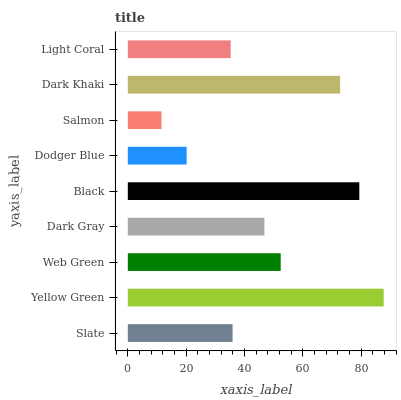Is Salmon the minimum?
Answer yes or no. Yes. Is Yellow Green the maximum?
Answer yes or no. Yes. Is Web Green the minimum?
Answer yes or no. No. Is Web Green the maximum?
Answer yes or no. No. Is Yellow Green greater than Web Green?
Answer yes or no. Yes. Is Web Green less than Yellow Green?
Answer yes or no. Yes. Is Web Green greater than Yellow Green?
Answer yes or no. No. Is Yellow Green less than Web Green?
Answer yes or no. No. Is Dark Gray the high median?
Answer yes or no. Yes. Is Dark Gray the low median?
Answer yes or no. Yes. Is Light Coral the high median?
Answer yes or no. No. Is Slate the low median?
Answer yes or no. No. 